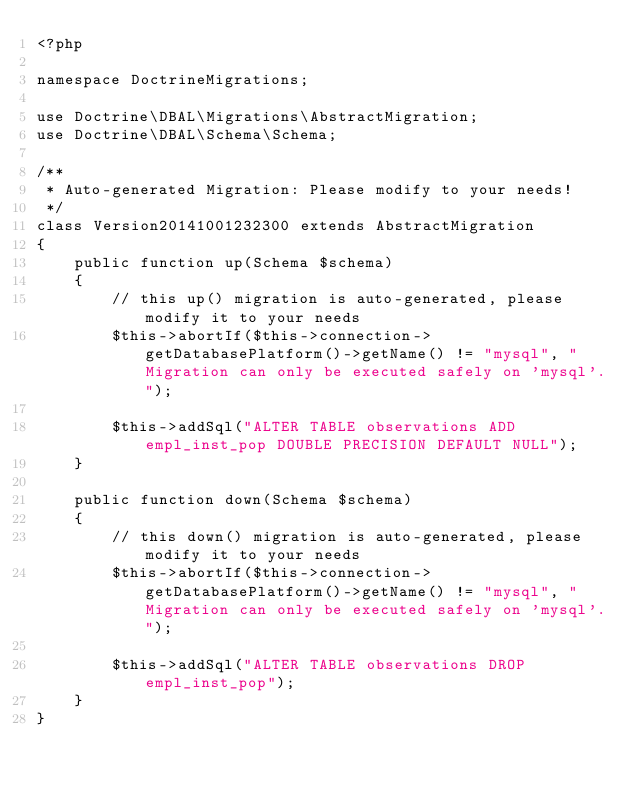Convert code to text. <code><loc_0><loc_0><loc_500><loc_500><_PHP_><?php

namespace DoctrineMigrations;

use Doctrine\DBAL\Migrations\AbstractMigration;
use Doctrine\DBAL\Schema\Schema;

/**
 * Auto-generated Migration: Please modify to your needs!
 */
class Version20141001232300 extends AbstractMigration
{
    public function up(Schema $schema)
    {
        // this up() migration is auto-generated, please modify it to your needs
        $this->abortIf($this->connection->getDatabasePlatform()->getName() != "mysql", "Migration can only be executed safely on 'mysql'.");
        
        $this->addSql("ALTER TABLE observations ADD empl_inst_pop DOUBLE PRECISION DEFAULT NULL");
    }

    public function down(Schema $schema)
    {
        // this down() migration is auto-generated, please modify it to your needs
        $this->abortIf($this->connection->getDatabasePlatform()->getName() != "mysql", "Migration can only be executed safely on 'mysql'.");
        
        $this->addSql("ALTER TABLE observations DROP empl_inst_pop");
    }
}
</code> 